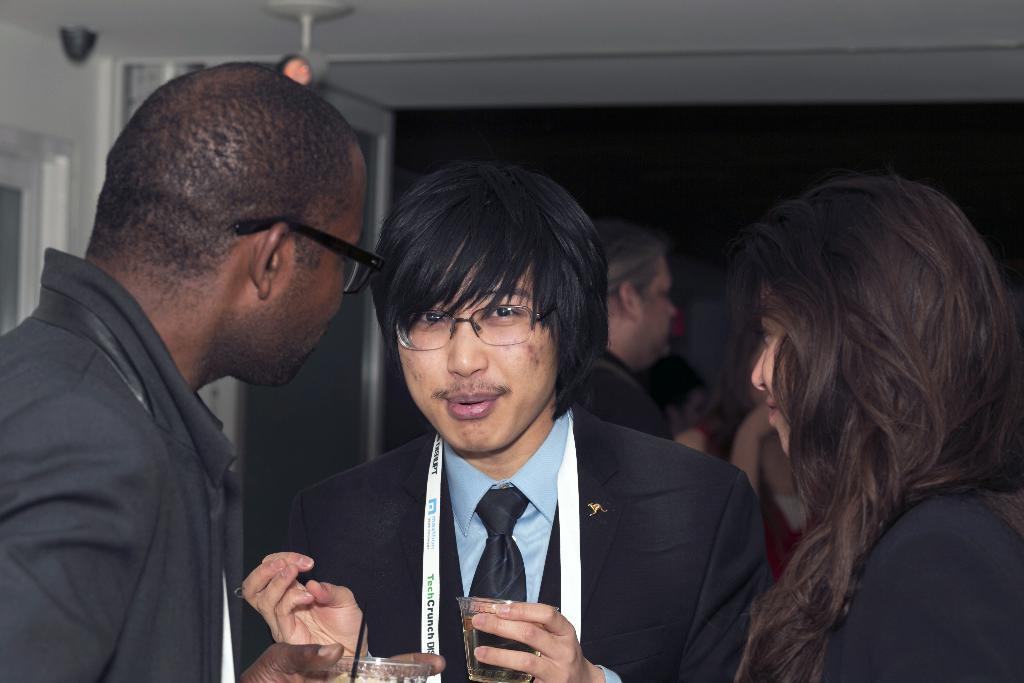Describe this image in one or two sentences. In the image we can see there are people standing and there are men holding wine glass in their hand. 